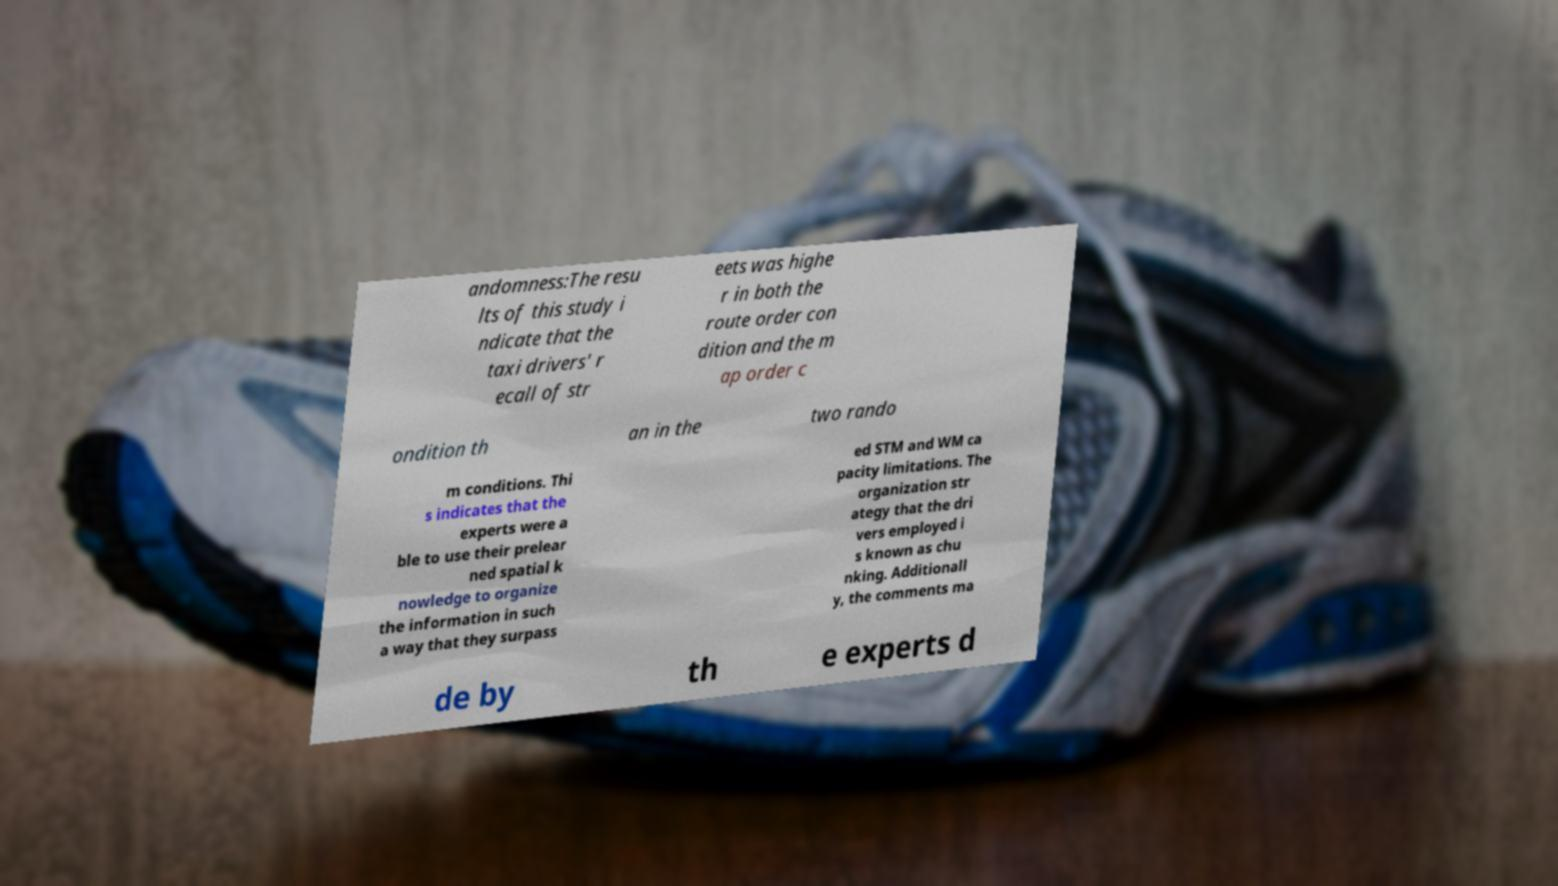Could you extract and type out the text from this image? andomness:The resu lts of this study i ndicate that the taxi drivers' r ecall of str eets was highe r in both the route order con dition and the m ap order c ondition th an in the two rando m conditions. Thi s indicates that the experts were a ble to use their prelear ned spatial k nowledge to organize the information in such a way that they surpass ed STM and WM ca pacity limitations. The organization str ategy that the dri vers employed i s known as chu nking. Additionall y, the comments ma de by th e experts d 